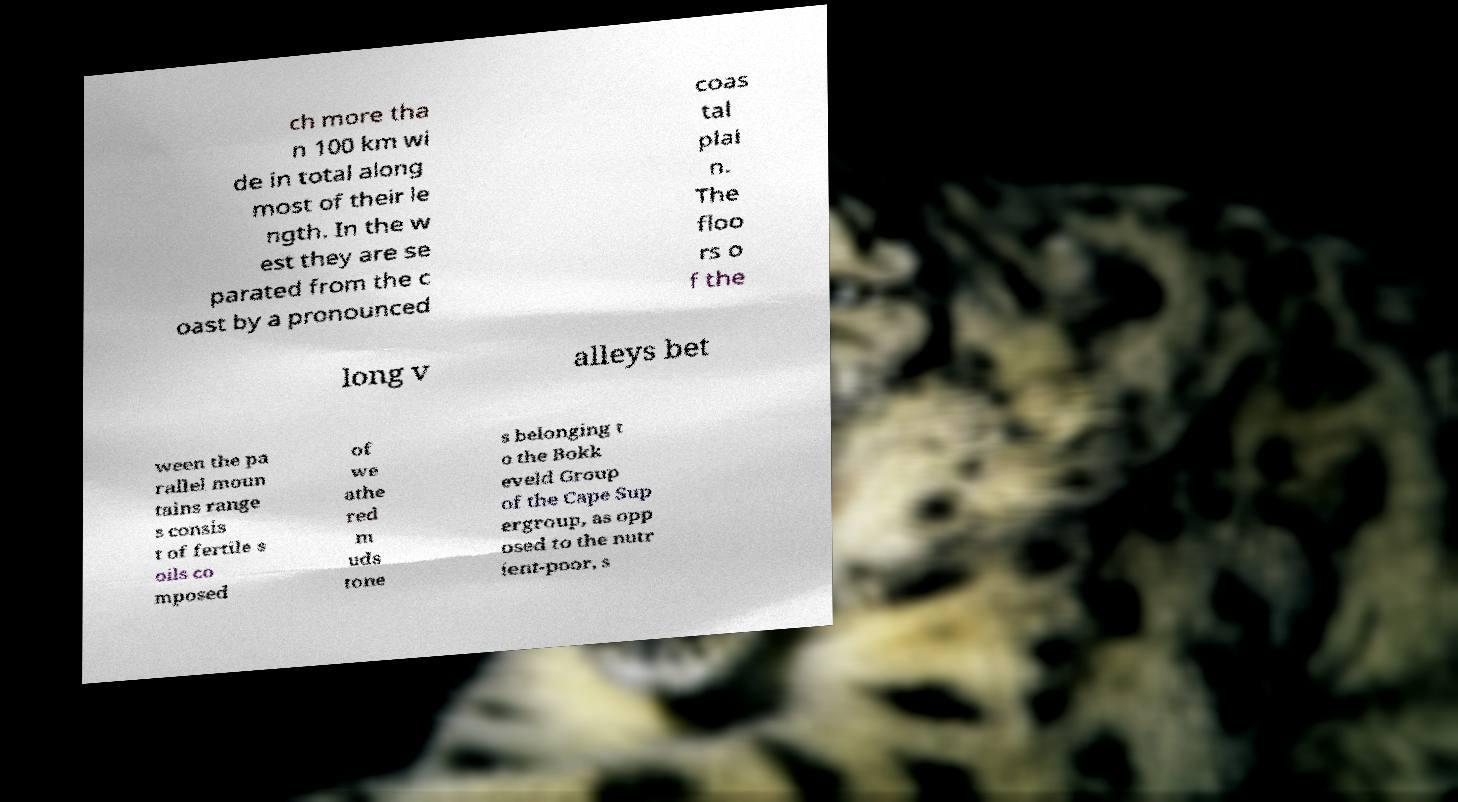Can you read and provide the text displayed in the image?This photo seems to have some interesting text. Can you extract and type it out for me? ch more tha n 100 km wi de in total along most of their le ngth. In the w est they are se parated from the c oast by a pronounced coas tal plai n. The floo rs o f the long v alleys bet ween the pa rallel moun tains range s consis t of fertile s oils co mposed of we athe red m uds tone s belonging t o the Bokk eveld Group of the Cape Sup ergroup, as opp osed to the nutr ient-poor, s 